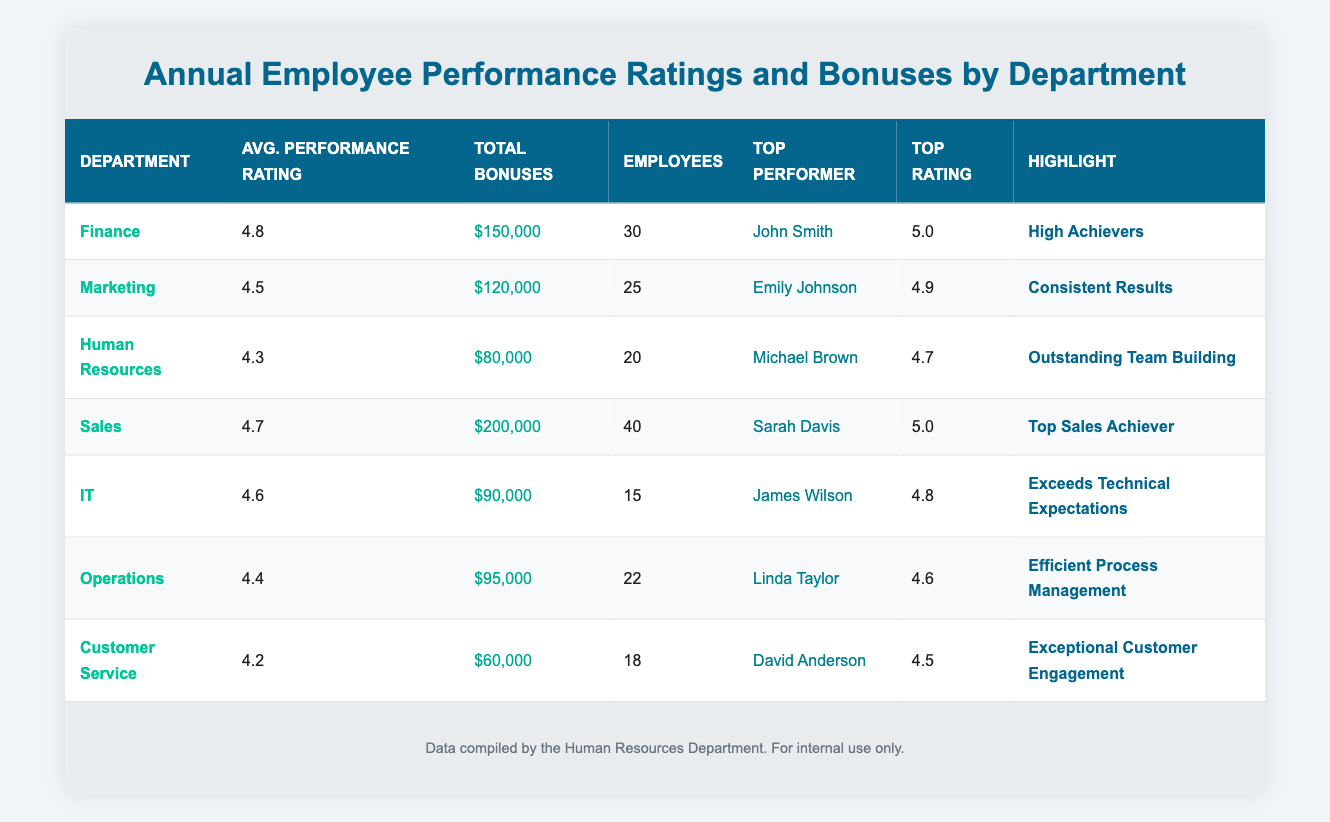What is the average performance rating for the IT department? The table shows that the average performance rating for the IT department is 4.6.
Answer: 4.6 Which department has the highest total bonuses disbursed? By comparing the total bonuses of all departments listed, Sales has the highest total with $200,000.
Answer: Sales What is the top performance rating in the Human Resources department? The top performer in the Human Resources department is Michael Brown with a top performance rating of 4.7.
Answer: 4.7 How many employees work in the Marketing department? The table indicates that there are 25 employees in the Marketing department.
Answer: 25 Is the average performance rating of the Customer Service department higher than 4.4? The average performance rating for Customer Service is 4.2, which is not higher than 4.4.
Answer: No Calculate the average performance rating for the Finance and Sales departments. The average for Finance is 4.8 and for Sales is 4.7. Adding these values gives 4.8 + 4.7 = 9.5, and dividing by 2 gives 9.5 / 2 = 4.75.
Answer: 4.75 Which department has the lowest total bonuses and what is that amount? Customer Service has the lowest total bonuses disbursed at $60,000, as determined by comparing all departments.
Answer: $60,000 Does the average performance rating of the Operations department exceed that of the Human Resources department? The Operations department has an average rating of 4.4, and Human Resources has 4.3. Since 4.4 is greater than 4.3, the answer is yes.
Answer: Yes If you combine the number of employees in the IT and Customer Service departments, how many employees would there be in total? IT has 15 employees and Customer Service has 18. Adding them gives 15 + 18 = 33 total employees.
Answer: 33 What is the highlight designation for the top performer in the Sales department? The highlight for the top performer, Sarah Davis, in the Sales department is "Top Sales Achiever," as shown in the table.
Answer: Top Sales Achiever 